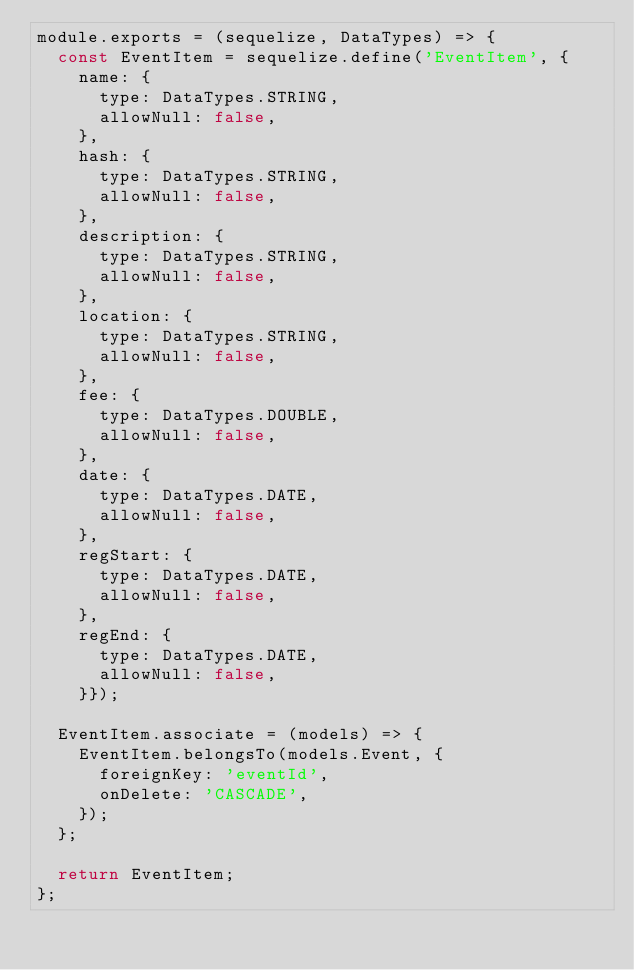Convert code to text. <code><loc_0><loc_0><loc_500><loc_500><_JavaScript_>module.exports = (sequelize, DataTypes) => {
  const EventItem = sequelize.define('EventItem', {
    name: {
      type: DataTypes.STRING,
      allowNull: false,
    },
    hash: {
      type: DataTypes.STRING,
      allowNull: false,
    },
    description: {
      type: DataTypes.STRING,
      allowNull: false,
    },
    location: {
      type: DataTypes.STRING,
      allowNull: false,
    },
    fee: {
      type: DataTypes.DOUBLE,
      allowNull: false,
    },
    date: {
      type: DataTypes.DATE,
      allowNull: false,
    },
    regStart: {
      type: DataTypes.DATE,
      allowNull: false,
    },
    regEnd: {
      type: DataTypes.DATE,
      allowNull: false,
    }});
    
  EventItem.associate = (models) => {
    EventItem.belongsTo(models.Event, {
      foreignKey: 'eventId',
      onDelete: 'CASCADE',
    });
  };

  return EventItem;
};</code> 